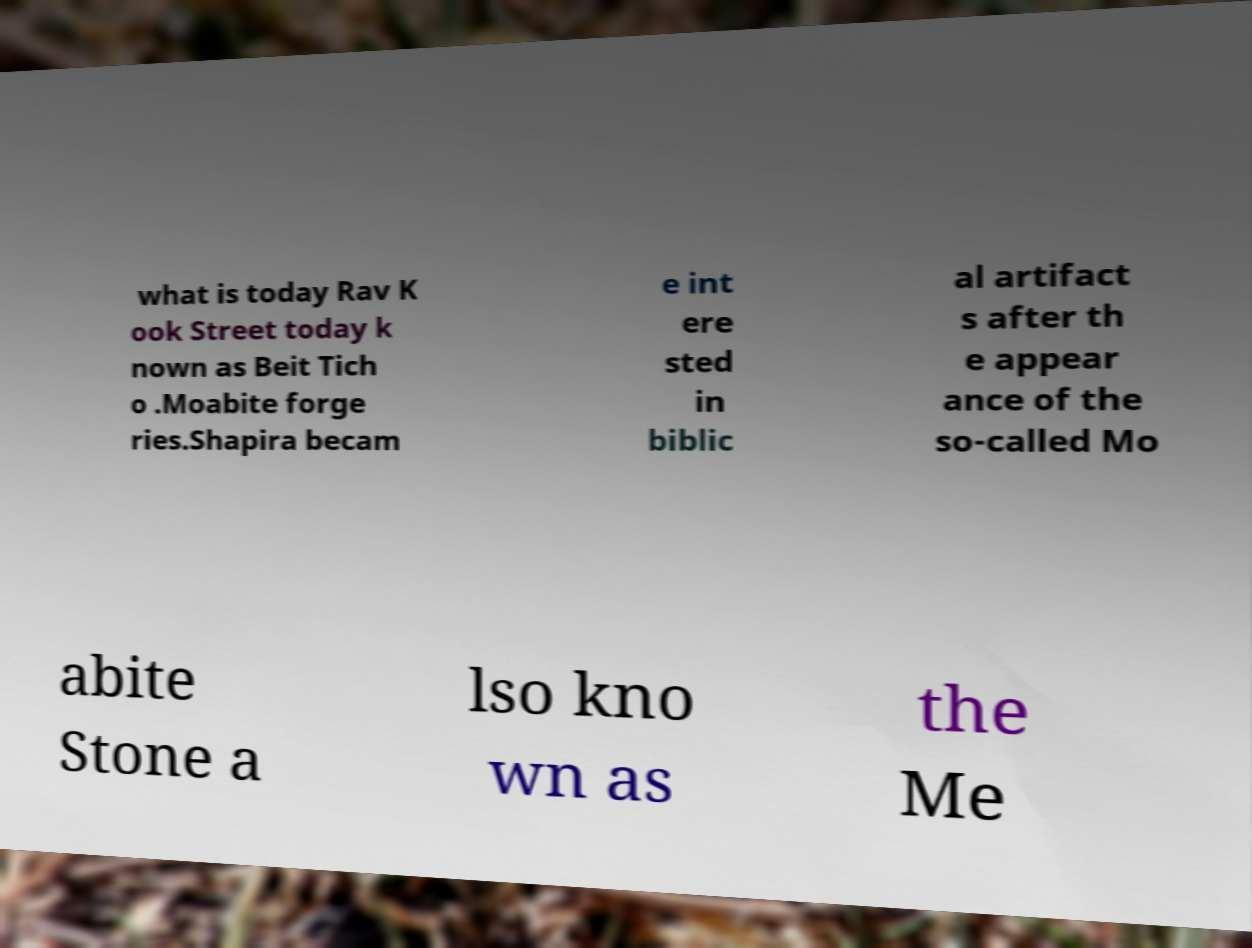Could you extract and type out the text from this image? what is today Rav K ook Street today k nown as Beit Tich o .Moabite forge ries.Shapira becam e int ere sted in biblic al artifact s after th e appear ance of the so-called Mo abite Stone a lso kno wn as the Me 